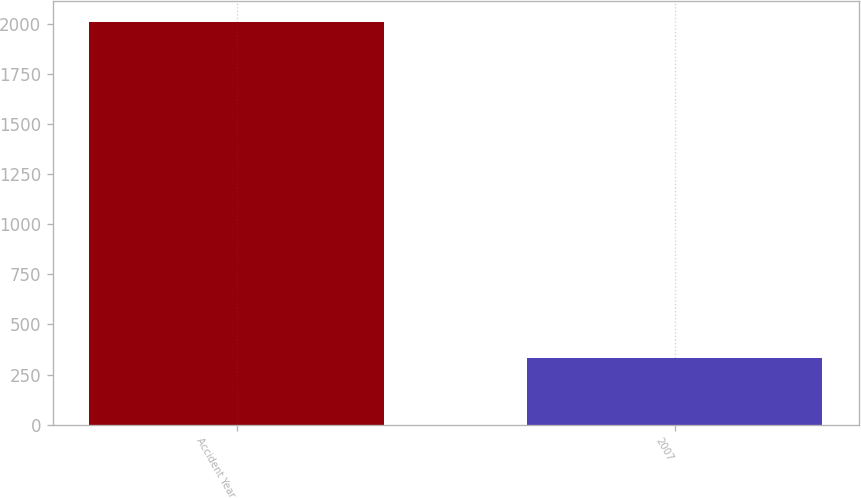<chart> <loc_0><loc_0><loc_500><loc_500><bar_chart><fcel>Accident Year<fcel>2007<nl><fcel>2012<fcel>334<nl></chart> 